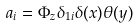<formula> <loc_0><loc_0><loc_500><loc_500>a _ { i } = \Phi _ { z } \delta _ { 1 i } \delta ( x ) \theta ( y )</formula> 